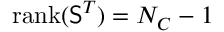Convert formula to latex. <formula><loc_0><loc_0><loc_500><loc_500>r a n k ( { \mathsf S } ^ { T } ) = N _ { C } - 1</formula> 